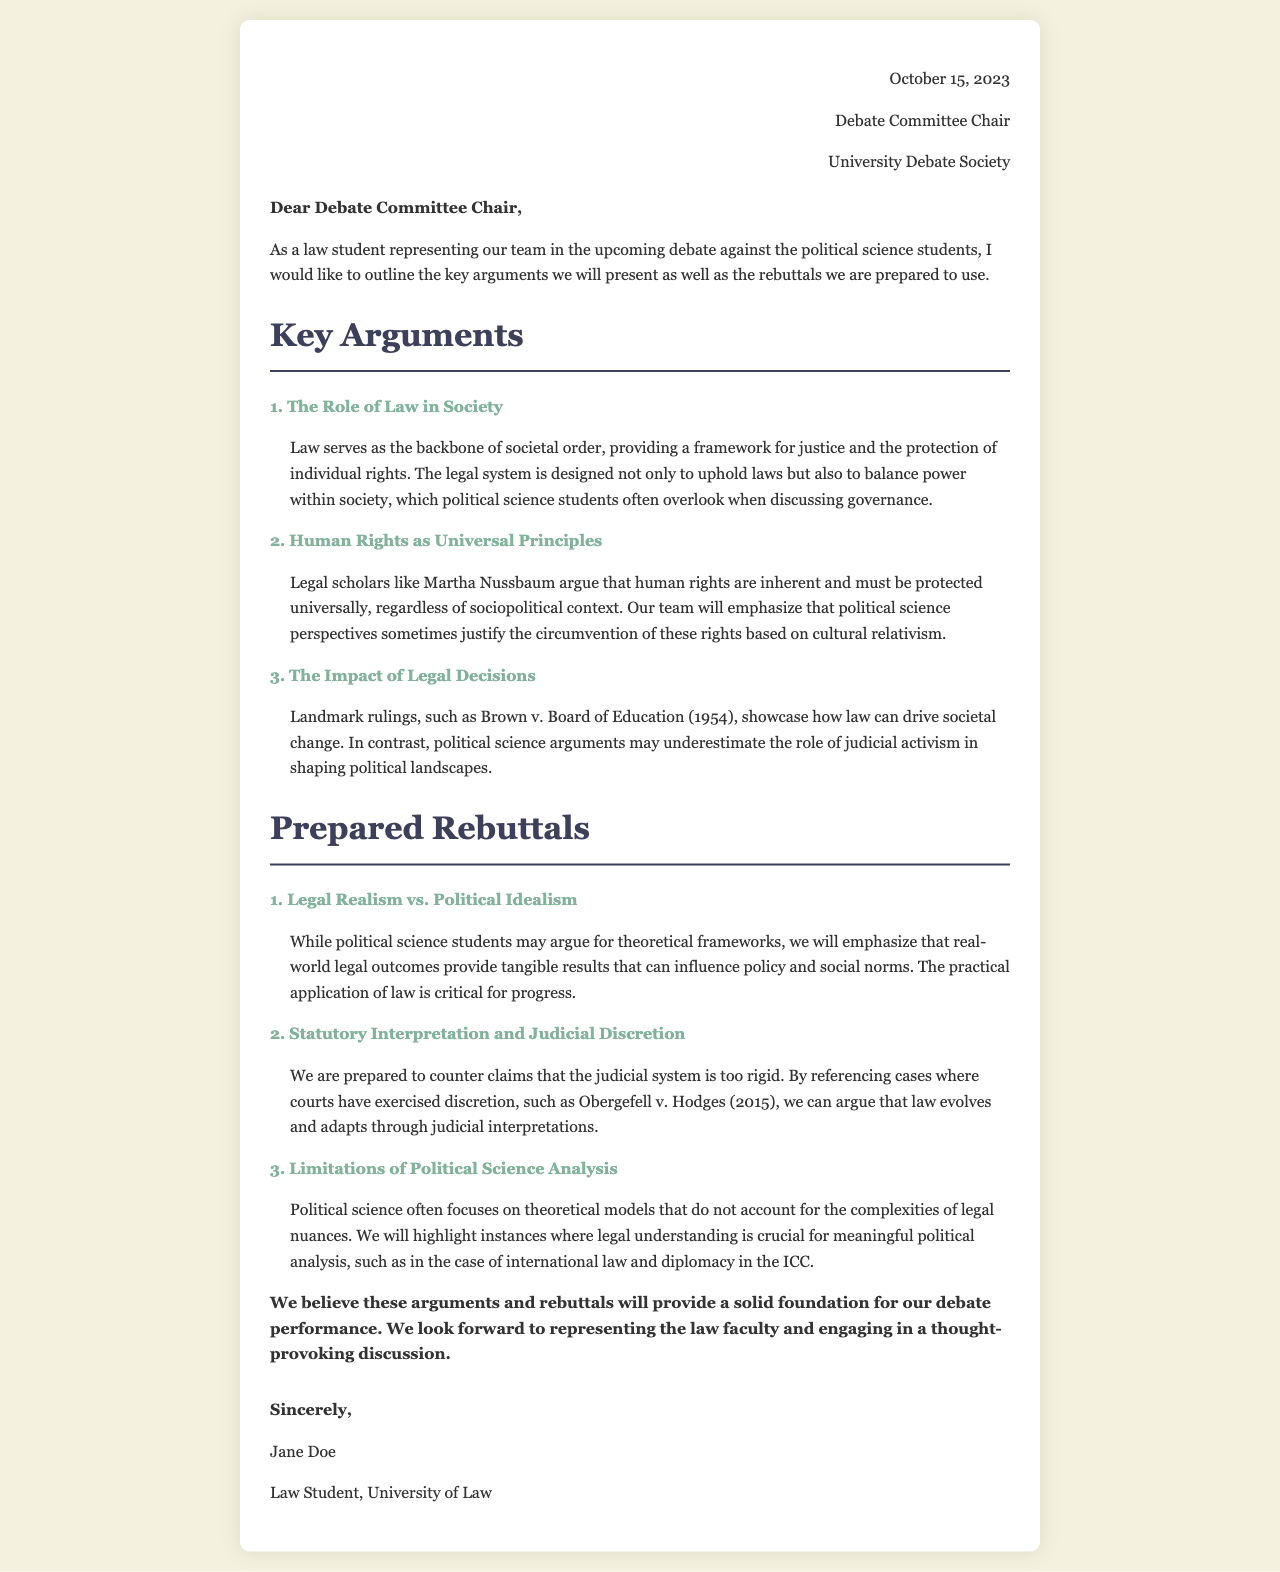What is the date of the letter? The date of the letter is mentioned in the header section of the document as October 15, 2023.
Answer: October 15, 2023 Who is the sign-off of the letter? The sign-off can be found at the end of the document where the writer's name is provided.
Answer: Jane Doe What is the first key argument listed in the letter? The key arguments are numbered, and the first one is stated clearly after the heading "Key Arguments."
Answer: The Role of Law in Society What landmark ruling is cited in the arguments? The document provides a specific example of a significant legal case to support the argument regarding legal decisions.
Answer: Brown v. Board of Education What rebuttal is prepared for claims about judicial rigidity? The rebuttals section addresses claims on a specific aspect of judicial discretion through a highlighted case.
Answer: Obergefell v. Hodges How does the letter describe political science analysis? The document provides a critical view on political science analysis in the rebuttals section, emphasizing its limitations.
Answer: Limitations of Political Science Analysis What type of document is this? The content and structure suggest the document serves a specific formal purpose.
Answer: Letter What is the closing statement of the letter? The closing statement reflects the writer's sentiment about the upcoming debate and is found at the end of the document.
Answer: We believe these arguments and rebuttals will provide a solid foundation for our debate performance 